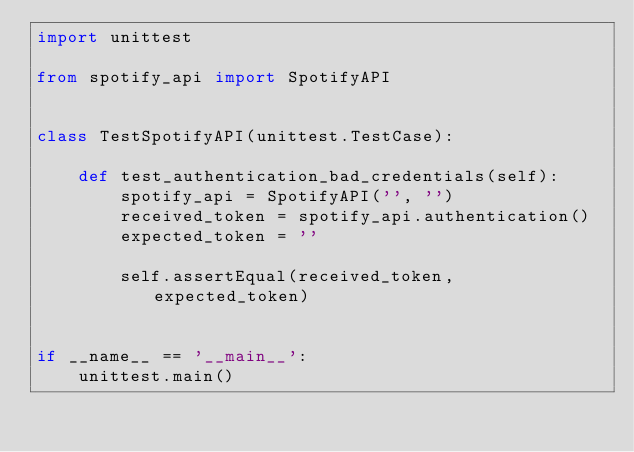<code> <loc_0><loc_0><loc_500><loc_500><_Python_>import unittest

from spotify_api import SpotifyAPI


class TestSpotifyAPI(unittest.TestCase):

    def test_authentication_bad_credentials(self):
        spotify_api = SpotifyAPI('', '')
        received_token = spotify_api.authentication()
        expected_token = ''

        self.assertEqual(received_token, expected_token)


if __name__ == '__main__':
    unittest.main()
</code> 